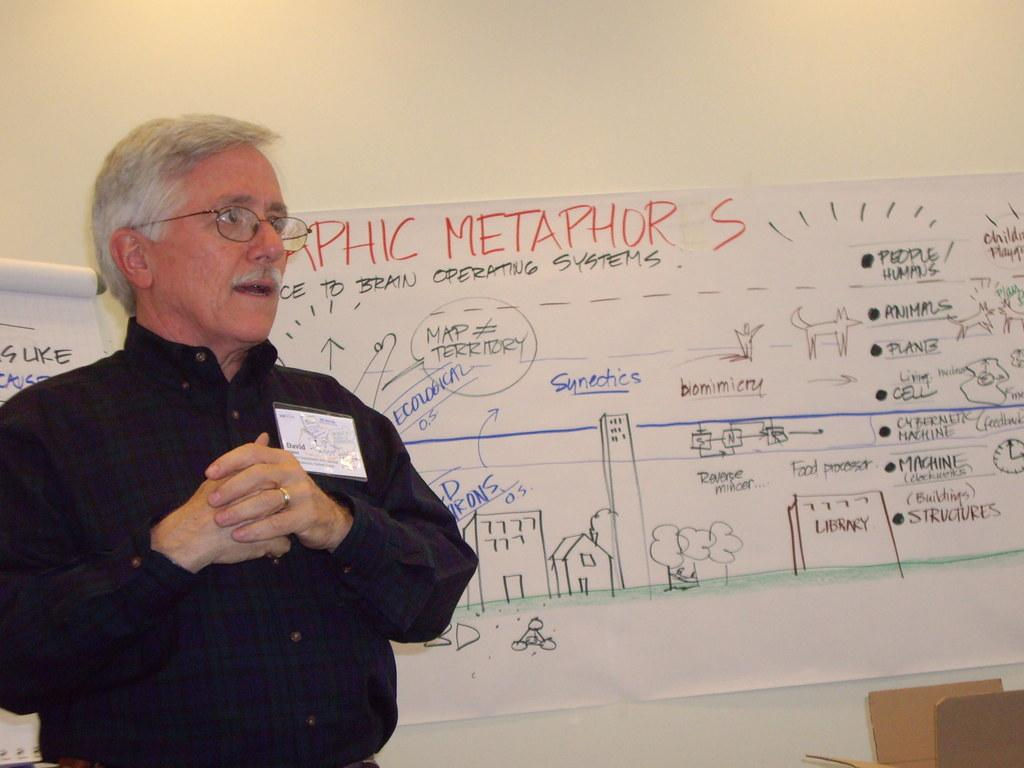<image>
Share a concise interpretation of the image provided. A man in front of a white board full of notes including Graphic Metaphors. 